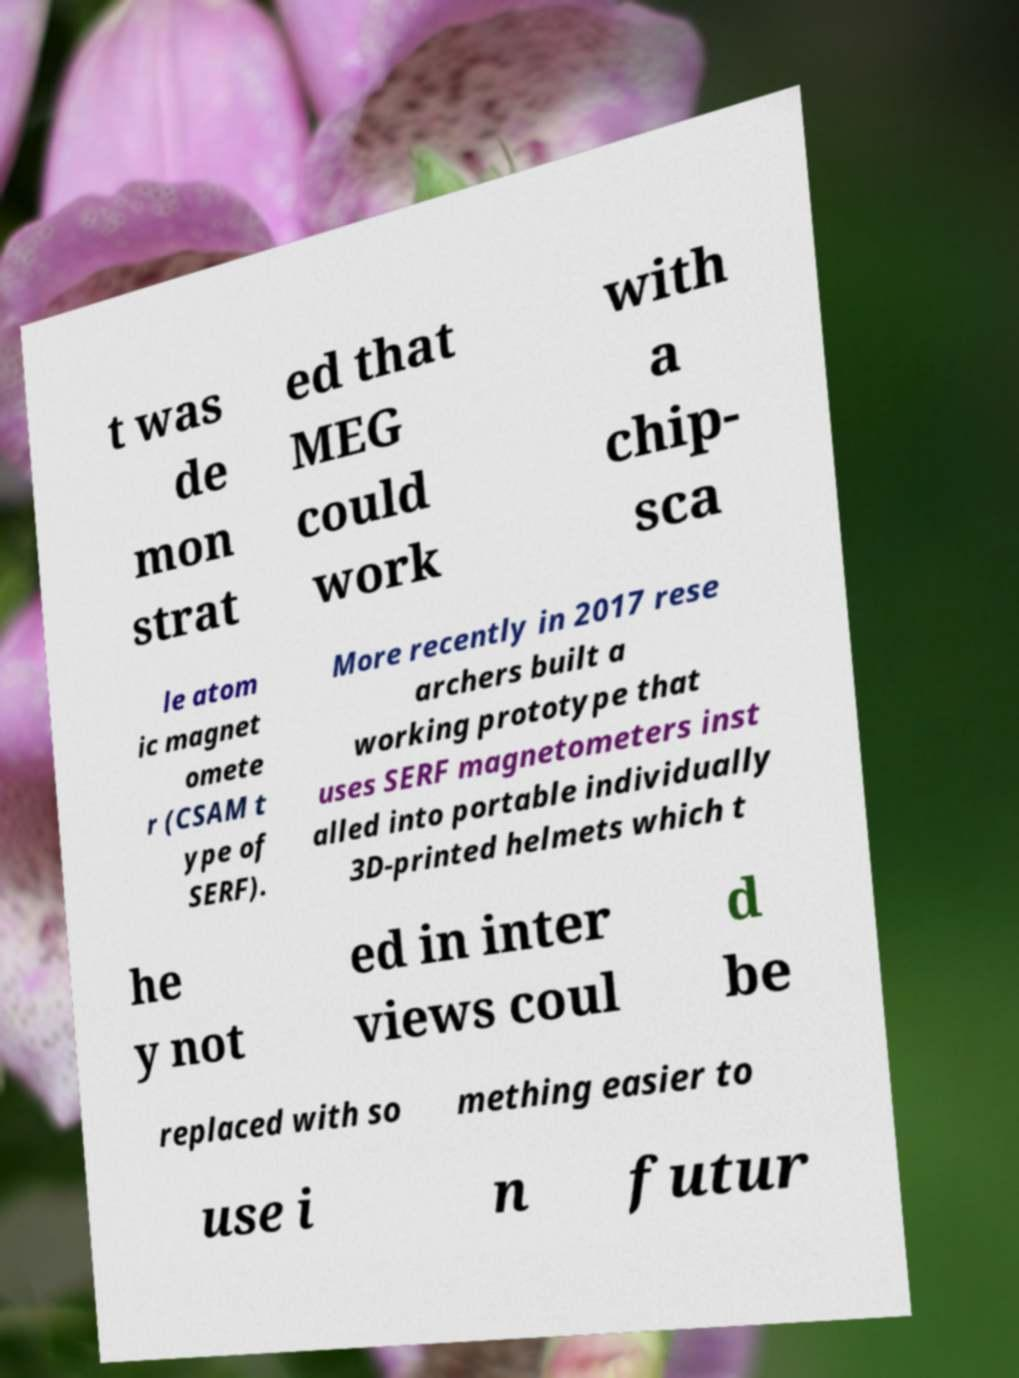Please identify and transcribe the text found in this image. t was de mon strat ed that MEG could work with a chip- sca le atom ic magnet omete r (CSAM t ype of SERF). More recently in 2017 rese archers built a working prototype that uses SERF magnetometers inst alled into portable individually 3D-printed helmets which t he y not ed in inter views coul d be replaced with so mething easier to use i n futur 